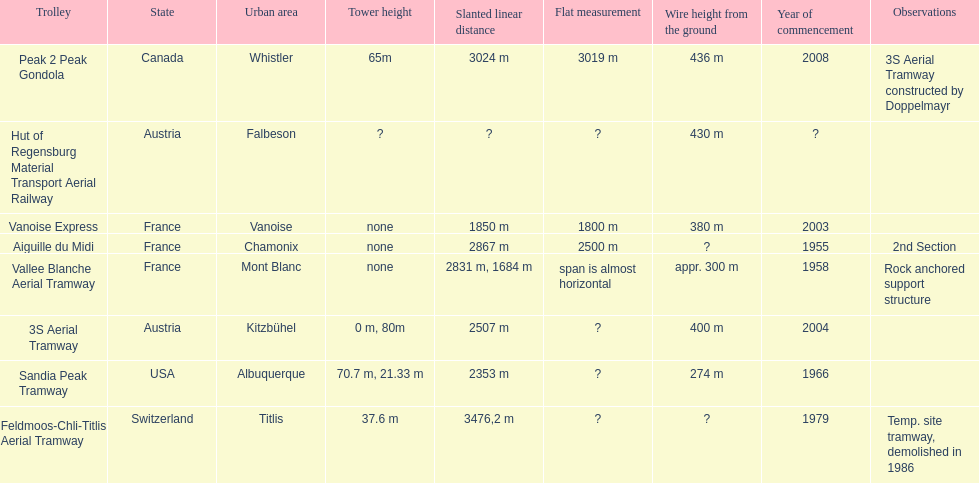Could you help me parse every detail presented in this table? {'header': ['Trolley', 'State', 'Urban area', 'Tower height', 'Slanted linear distance', 'Flat measurement', 'Wire height from the ground', 'Year of commencement', 'Observations'], 'rows': [['Peak 2 Peak Gondola', 'Canada', 'Whistler', '65m', '3024 m', '3019 m', '436 m', '2008', '3S Aerial Tramway constructed by Doppelmayr'], ['Hut of Regensburg Material Transport Aerial Railway', 'Austria', 'Falbeson', '?', '?', '?', '430 m', '?', ''], ['Vanoise Express', 'France', 'Vanoise', 'none', '1850 m', '1800 m', '380 m', '2003', ''], ['Aiguille du Midi', 'France', 'Chamonix', 'none', '2867 m', '2500 m', '?', '1955', '2nd Section'], ['Vallee Blanche Aerial Tramway', 'France', 'Mont Blanc', 'none', '2831 m, 1684 m', 'span is almost horizontal', 'appr. 300 m', '1958', 'Rock anchored support structure'], ['3S Aerial Tramway', 'Austria', 'Kitzbühel', '0 m, 80m', '2507 m', '?', '400 m', '2004', ''], ['Sandia Peak Tramway', 'USA', 'Albuquerque', '70.7 m, 21.33 m', '2353 m', '?', '274 m', '1966', ''], ['Feldmoos-Chli-Titlis Aerial Tramway', 'Switzerland', 'Titlis', '37.6 m', '3476,2 m', '?', '?', '1979', 'Temp. site tramway, demolished in 1986']]} Was the peak 2 peak gondola inaugurated before the vanoise express? No. 